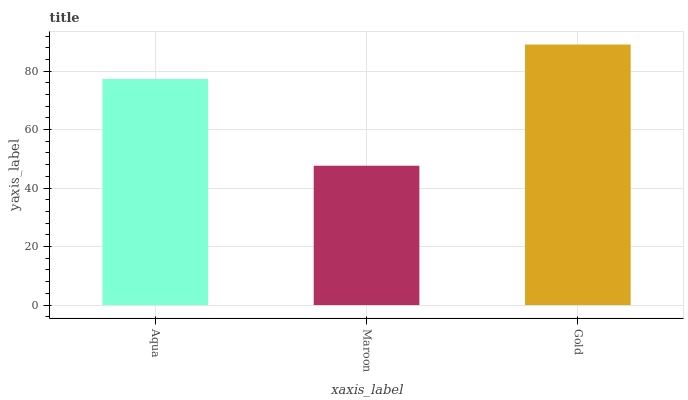Is Maroon the minimum?
Answer yes or no. Yes. Is Gold the maximum?
Answer yes or no. Yes. Is Gold the minimum?
Answer yes or no. No. Is Maroon the maximum?
Answer yes or no. No. Is Gold greater than Maroon?
Answer yes or no. Yes. Is Maroon less than Gold?
Answer yes or no. Yes. Is Maroon greater than Gold?
Answer yes or no. No. Is Gold less than Maroon?
Answer yes or no. No. Is Aqua the high median?
Answer yes or no. Yes. Is Aqua the low median?
Answer yes or no. Yes. Is Maroon the high median?
Answer yes or no. No. Is Gold the low median?
Answer yes or no. No. 